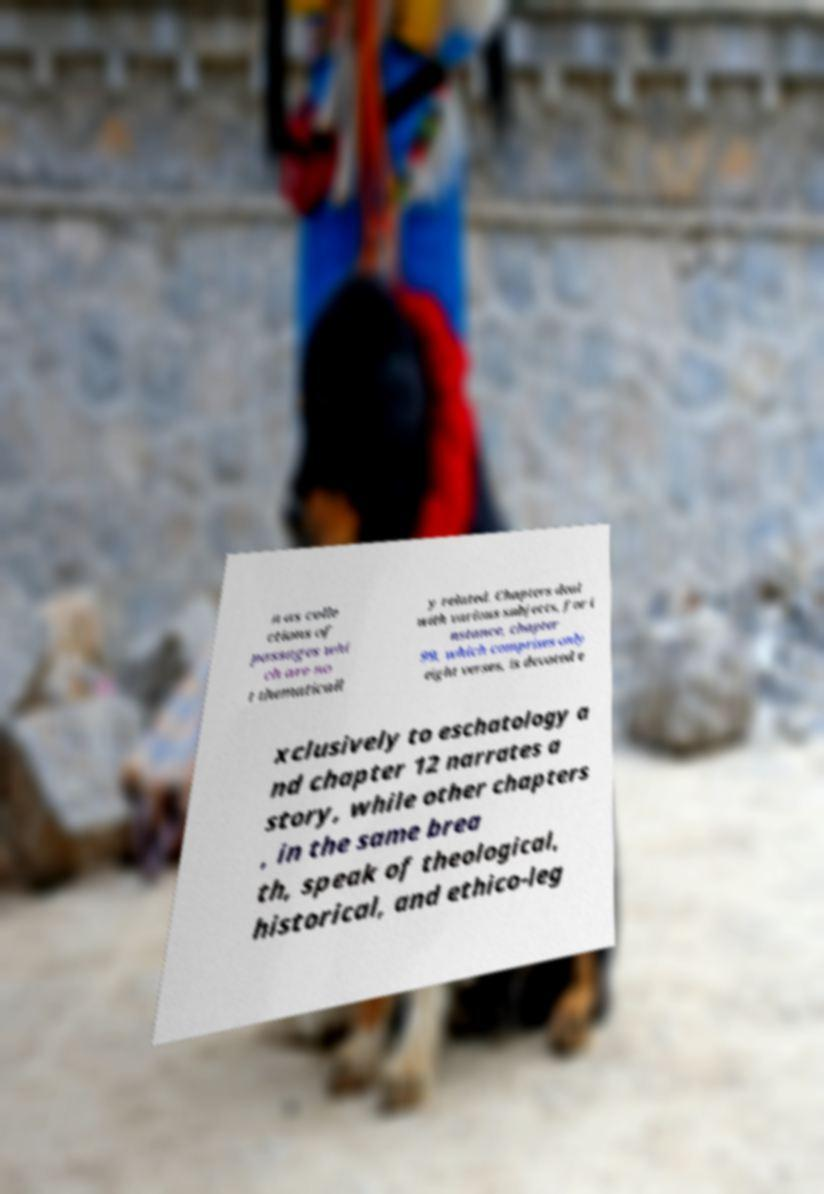Could you assist in decoding the text presented in this image and type it out clearly? n as colle ctions of passages whi ch are no t thematicall y related. Chapters deal with various subjects, for i nstance, chapter 99, which comprises only eight verses, is devoted e xclusively to eschatology a nd chapter 12 narrates a story, while other chapters , in the same brea th, speak of theological, historical, and ethico-leg 